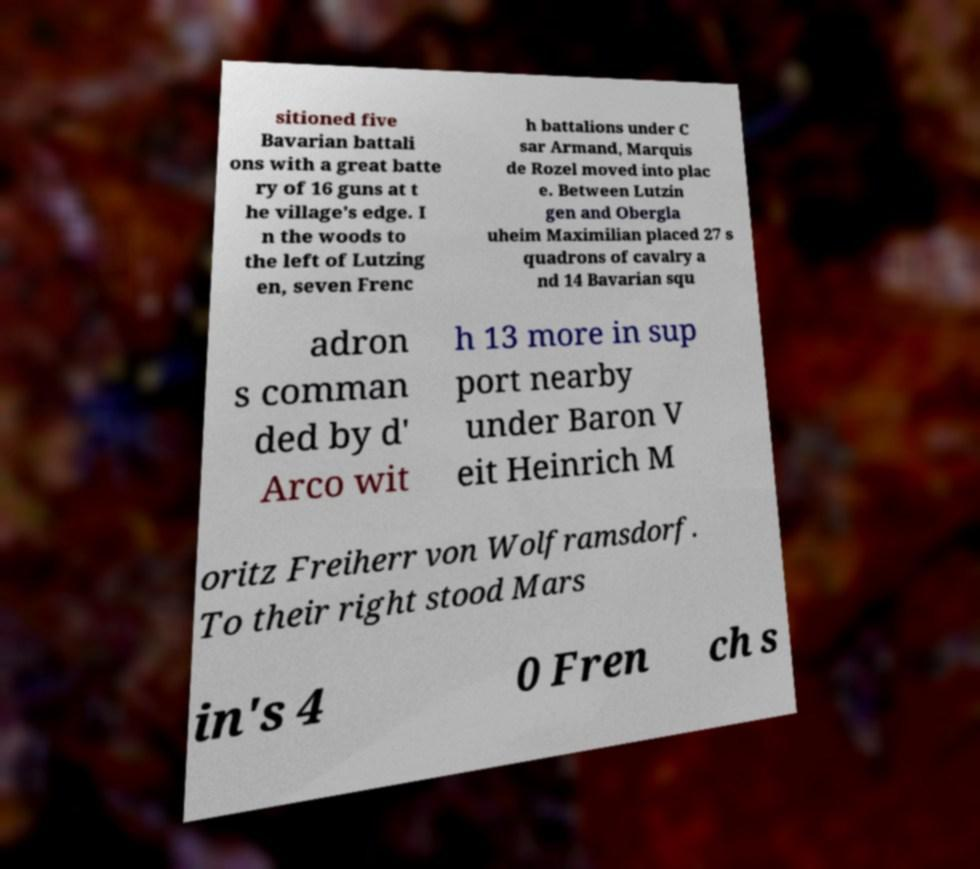Can you read and provide the text displayed in the image?This photo seems to have some interesting text. Can you extract and type it out for me? sitioned five Bavarian battali ons with a great batte ry of 16 guns at t he village's edge. I n the woods to the left of Lutzing en, seven Frenc h battalions under C sar Armand, Marquis de Rozel moved into plac e. Between Lutzin gen and Obergla uheim Maximilian placed 27 s quadrons of cavalry a nd 14 Bavarian squ adron s comman ded by d' Arco wit h 13 more in sup port nearby under Baron V eit Heinrich M oritz Freiherr von Wolframsdorf. To their right stood Mars in's 4 0 Fren ch s 